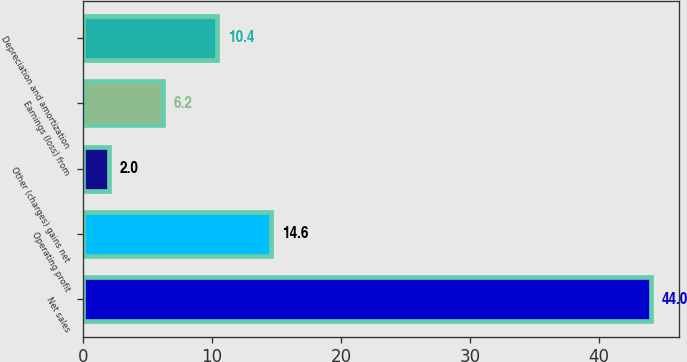Convert chart to OTSL. <chart><loc_0><loc_0><loc_500><loc_500><bar_chart><fcel>Net sales<fcel>Operating profit<fcel>Other (charges) gains net<fcel>Earnings (loss) from<fcel>Depreciation and amortization<nl><fcel>44<fcel>14.6<fcel>2<fcel>6.2<fcel>10.4<nl></chart> 